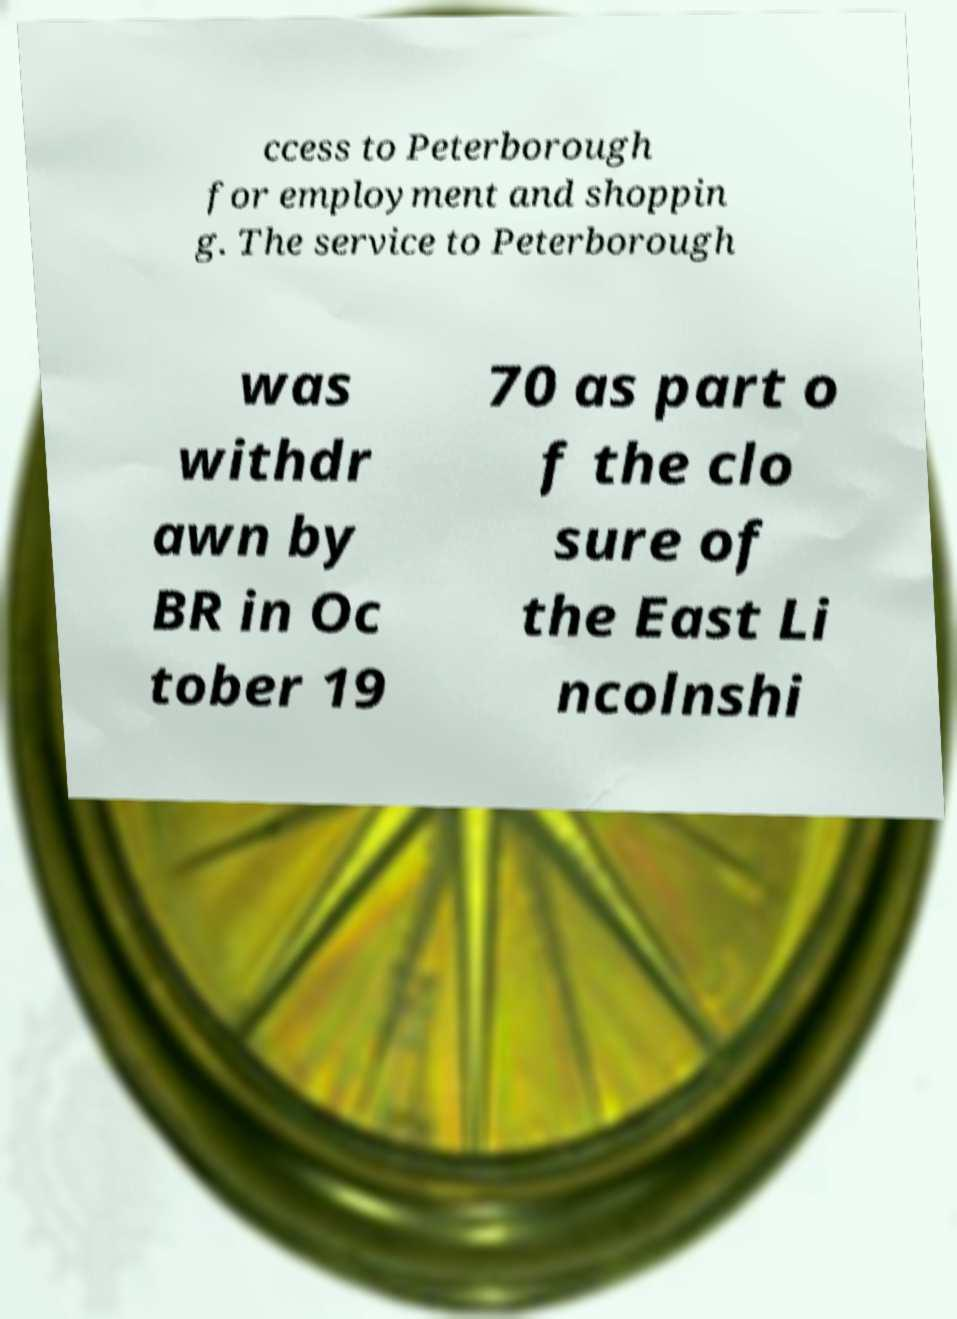Could you extract and type out the text from this image? ccess to Peterborough for employment and shoppin g. The service to Peterborough was withdr awn by BR in Oc tober 19 70 as part o f the clo sure of the East Li ncolnshi 